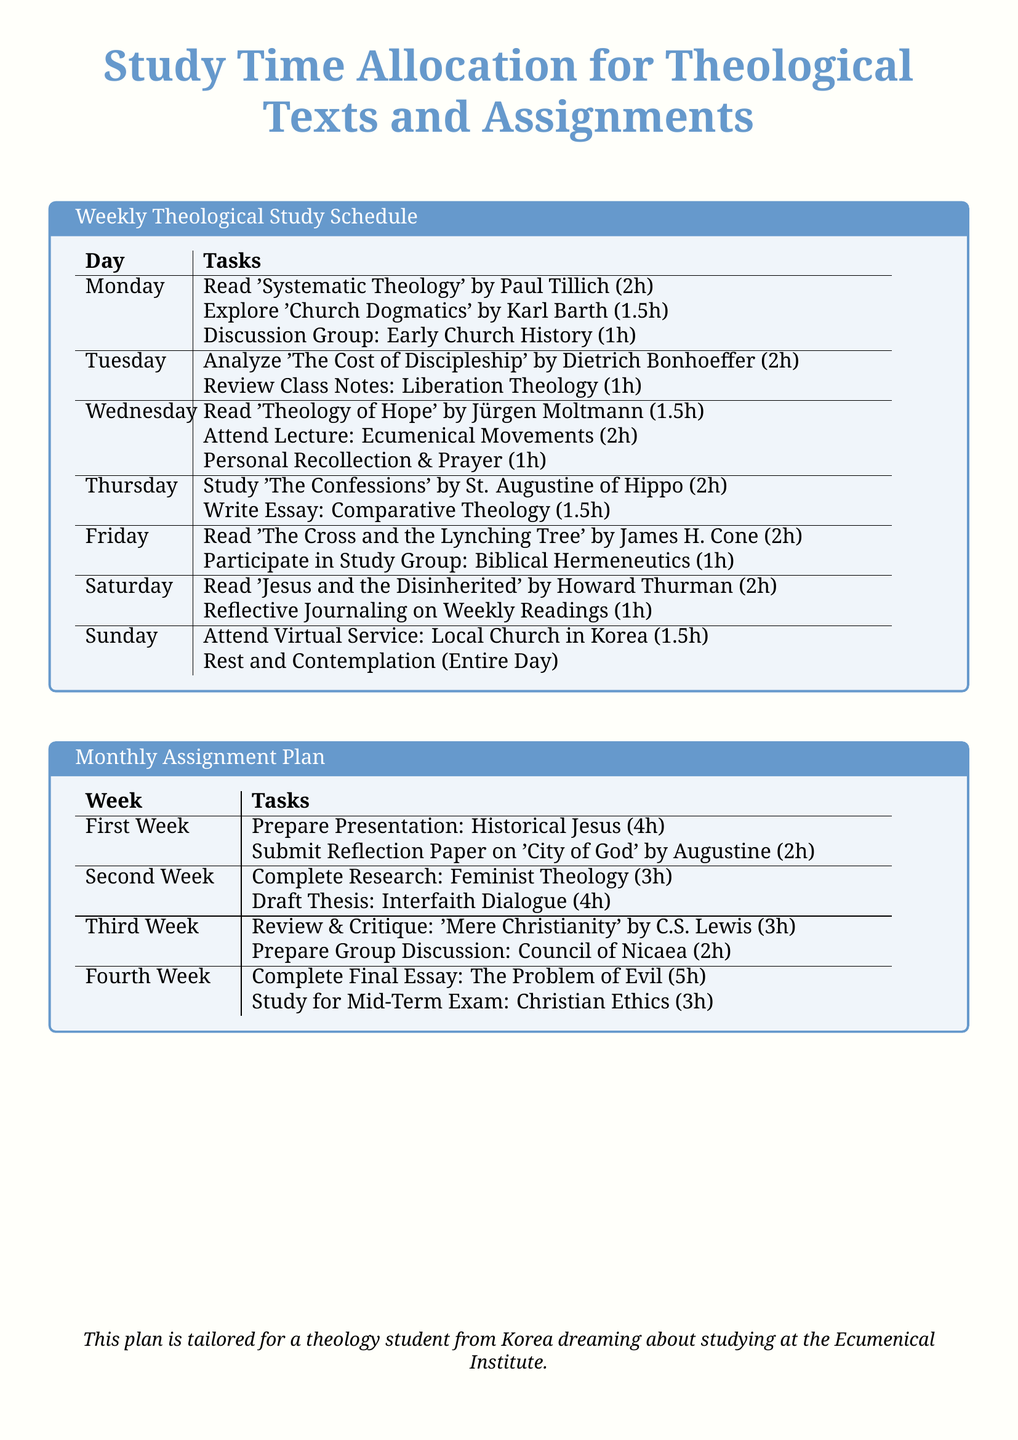What is the total study time for Monday? The total study time is calculated by summing the hours of all tasks listed for Monday, which is 2h + 1.5h + 1h = 4.5h.
Answer: 4.5h Which book is studied on Thursday? The book studied on Thursday is mentioned in the tasks for that day in the document.
Answer: The Confessions How many hours are allocated for the Final Essay in the Fourth Week? The allocation for the Final Essay in the Fourth Week is specifically stated in the Monthly Assignment Plan.
Answer: 5h What kind of session is attended on Sunday? The type of session attended on Sunday is indicated in the tasks for that day.
Answer: Virtual Service How many hours are dedicated to Reflective Journaling on Saturday? The number of hours dedicated to Reflective Journaling is clearly stated in the schedule.
Answer: 1h What is the focus of the analysis on Tuesday? The focus of the analysis on Tuesday is specified in the tasks listed for that day.
Answer: The Cost of Discipleship How much time is allocated for the group discussion in the Third Week? The time allocated for the group discussion in the Third Week can be found in the Monthly Assignment Plan.
Answer: 2h Which theologian's work is reviewed on Wednesday? The theologian's work reviewed on Wednesday is identified in the reading tasks for that day.
Answer: Jürgen Moltmann 